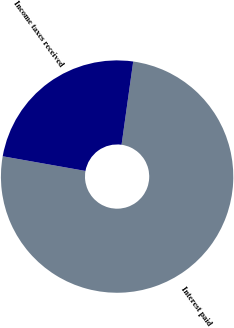Convert chart to OTSL. <chart><loc_0><loc_0><loc_500><loc_500><pie_chart><fcel>Interest paid<fcel>Income taxes received<nl><fcel>75.58%<fcel>24.42%<nl></chart> 